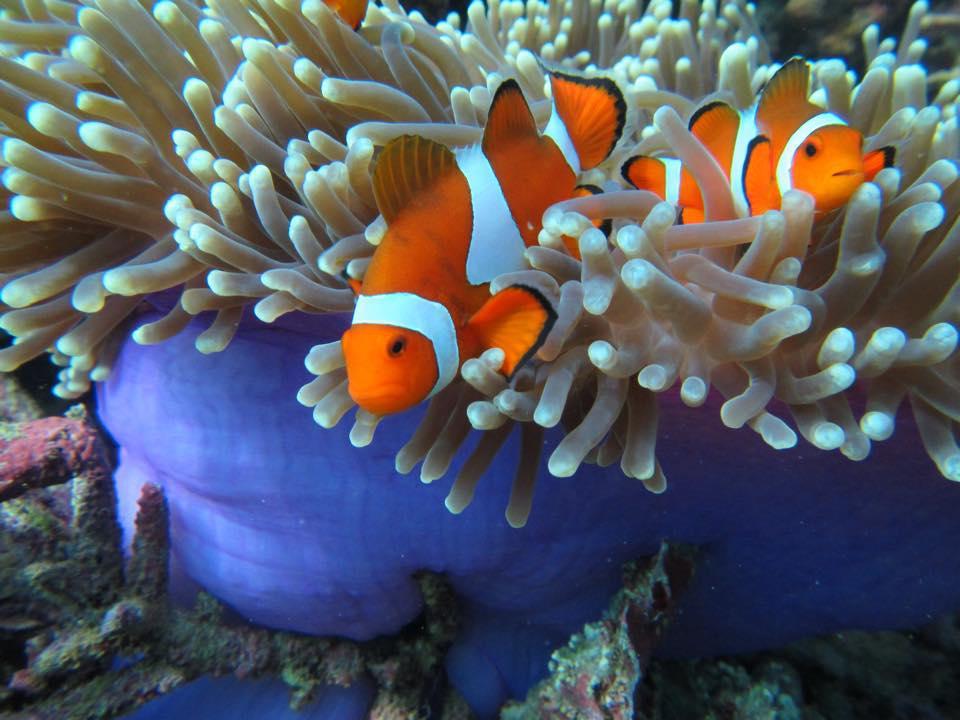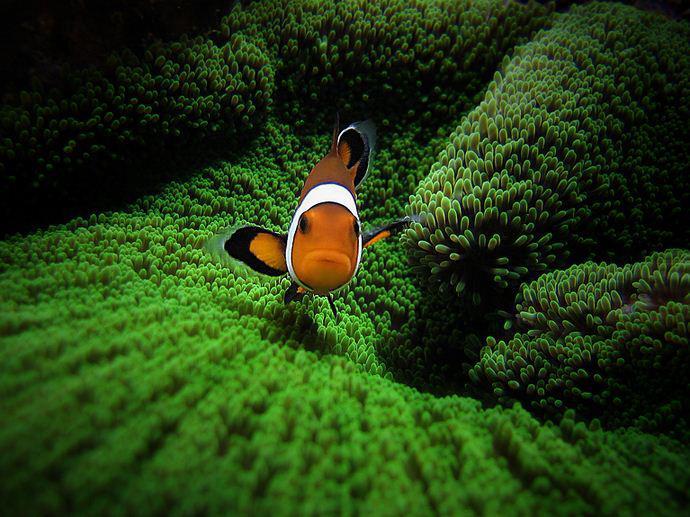The first image is the image on the left, the second image is the image on the right. Analyze the images presented: Is the assertion "There are two fish in the picture on the left." valid? Answer yes or no. Yes. 